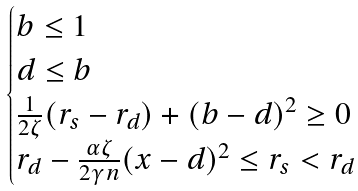Convert formula to latex. <formula><loc_0><loc_0><loc_500><loc_500>\begin{cases} b \leq 1 \\ d \leq b \\ \frac { 1 } { 2 \zeta } ( r _ { s } - r _ { d } ) + ( b - d ) ^ { 2 } \geq 0 \\ r _ { d } - \frac { \alpha \zeta } { 2 \gamma n } ( x - d ) ^ { 2 } \leq r _ { s } < r _ { d } \end{cases}</formula> 